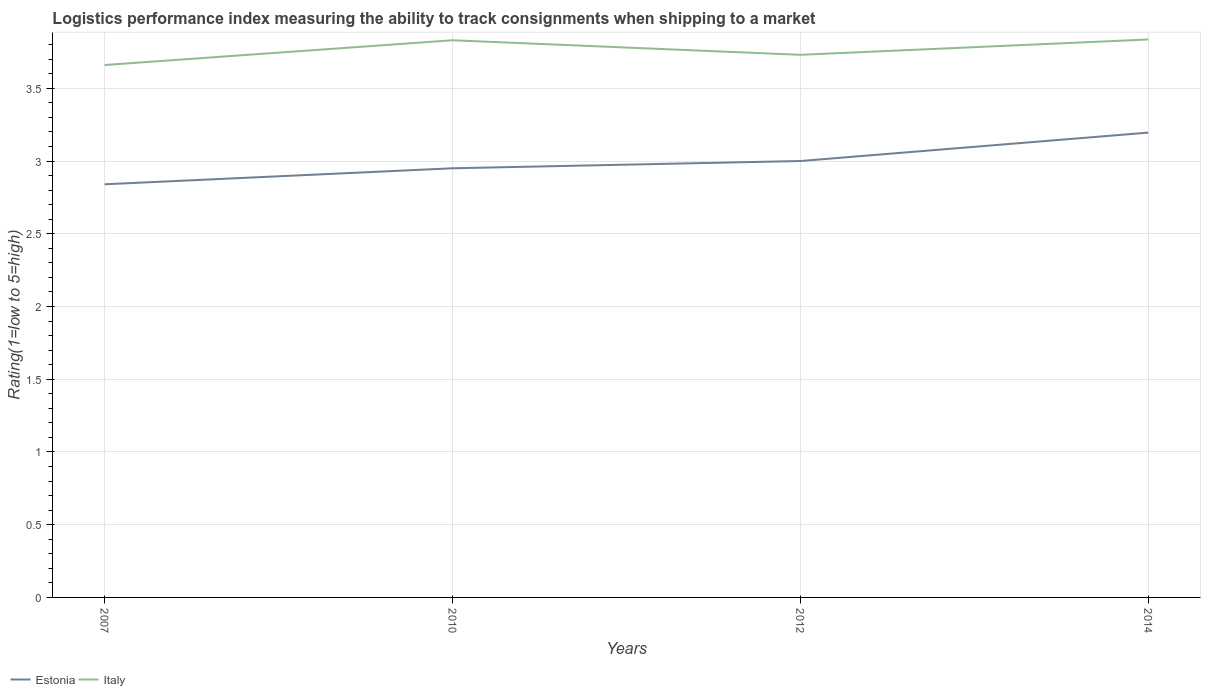How many different coloured lines are there?
Make the answer very short. 2. Is the number of lines equal to the number of legend labels?
Your answer should be compact. Yes. Across all years, what is the maximum Logistic performance index in Estonia?
Provide a succinct answer. 2.84. What is the total Logistic performance index in Estonia in the graph?
Your answer should be very brief. -0.36. What is the difference between the highest and the second highest Logistic performance index in Italy?
Provide a short and direct response. 0.18. What is the difference between the highest and the lowest Logistic performance index in Estonia?
Provide a short and direct response. 2. What is the difference between two consecutive major ticks on the Y-axis?
Your answer should be compact. 0.5. Does the graph contain any zero values?
Make the answer very short. No. Where does the legend appear in the graph?
Provide a succinct answer. Bottom left. What is the title of the graph?
Make the answer very short. Logistics performance index measuring the ability to track consignments when shipping to a market. What is the label or title of the X-axis?
Your answer should be very brief. Years. What is the label or title of the Y-axis?
Keep it short and to the point. Rating(1=low to 5=high). What is the Rating(1=low to 5=high) of Estonia in 2007?
Offer a terse response. 2.84. What is the Rating(1=low to 5=high) of Italy in 2007?
Provide a short and direct response. 3.66. What is the Rating(1=low to 5=high) in Estonia in 2010?
Make the answer very short. 2.95. What is the Rating(1=low to 5=high) of Italy in 2010?
Give a very brief answer. 3.83. What is the Rating(1=low to 5=high) of Italy in 2012?
Provide a short and direct response. 3.73. What is the Rating(1=low to 5=high) in Estonia in 2014?
Offer a terse response. 3.2. What is the Rating(1=low to 5=high) in Italy in 2014?
Ensure brevity in your answer.  3.84. Across all years, what is the maximum Rating(1=low to 5=high) of Estonia?
Provide a short and direct response. 3.2. Across all years, what is the maximum Rating(1=low to 5=high) in Italy?
Give a very brief answer. 3.84. Across all years, what is the minimum Rating(1=low to 5=high) of Estonia?
Provide a succinct answer. 2.84. Across all years, what is the minimum Rating(1=low to 5=high) of Italy?
Your answer should be very brief. 3.66. What is the total Rating(1=low to 5=high) of Estonia in the graph?
Your answer should be compact. 11.99. What is the total Rating(1=low to 5=high) in Italy in the graph?
Ensure brevity in your answer.  15.06. What is the difference between the Rating(1=low to 5=high) of Estonia in 2007 and that in 2010?
Provide a short and direct response. -0.11. What is the difference between the Rating(1=low to 5=high) in Italy in 2007 and that in 2010?
Your response must be concise. -0.17. What is the difference between the Rating(1=low to 5=high) of Estonia in 2007 and that in 2012?
Your response must be concise. -0.16. What is the difference between the Rating(1=low to 5=high) in Italy in 2007 and that in 2012?
Provide a short and direct response. -0.07. What is the difference between the Rating(1=low to 5=high) of Estonia in 2007 and that in 2014?
Give a very brief answer. -0.36. What is the difference between the Rating(1=low to 5=high) in Italy in 2007 and that in 2014?
Give a very brief answer. -0.18. What is the difference between the Rating(1=low to 5=high) of Estonia in 2010 and that in 2012?
Ensure brevity in your answer.  -0.05. What is the difference between the Rating(1=low to 5=high) of Italy in 2010 and that in 2012?
Ensure brevity in your answer.  0.1. What is the difference between the Rating(1=low to 5=high) in Estonia in 2010 and that in 2014?
Offer a terse response. -0.25. What is the difference between the Rating(1=low to 5=high) in Italy in 2010 and that in 2014?
Offer a very short reply. -0.01. What is the difference between the Rating(1=low to 5=high) in Estonia in 2012 and that in 2014?
Provide a succinct answer. -0.2. What is the difference between the Rating(1=low to 5=high) of Italy in 2012 and that in 2014?
Your response must be concise. -0.11. What is the difference between the Rating(1=low to 5=high) in Estonia in 2007 and the Rating(1=low to 5=high) in Italy in 2010?
Ensure brevity in your answer.  -0.99. What is the difference between the Rating(1=low to 5=high) in Estonia in 2007 and the Rating(1=low to 5=high) in Italy in 2012?
Ensure brevity in your answer.  -0.89. What is the difference between the Rating(1=low to 5=high) of Estonia in 2007 and the Rating(1=low to 5=high) of Italy in 2014?
Your response must be concise. -1. What is the difference between the Rating(1=low to 5=high) in Estonia in 2010 and the Rating(1=low to 5=high) in Italy in 2012?
Give a very brief answer. -0.78. What is the difference between the Rating(1=low to 5=high) of Estonia in 2010 and the Rating(1=low to 5=high) of Italy in 2014?
Keep it short and to the point. -0.89. What is the difference between the Rating(1=low to 5=high) of Estonia in 2012 and the Rating(1=low to 5=high) of Italy in 2014?
Provide a short and direct response. -0.84. What is the average Rating(1=low to 5=high) of Estonia per year?
Offer a terse response. 3. What is the average Rating(1=low to 5=high) in Italy per year?
Your answer should be very brief. 3.76. In the year 2007, what is the difference between the Rating(1=low to 5=high) in Estonia and Rating(1=low to 5=high) in Italy?
Make the answer very short. -0.82. In the year 2010, what is the difference between the Rating(1=low to 5=high) in Estonia and Rating(1=low to 5=high) in Italy?
Provide a short and direct response. -0.88. In the year 2012, what is the difference between the Rating(1=low to 5=high) in Estonia and Rating(1=low to 5=high) in Italy?
Provide a succinct answer. -0.73. In the year 2014, what is the difference between the Rating(1=low to 5=high) of Estonia and Rating(1=low to 5=high) of Italy?
Keep it short and to the point. -0.64. What is the ratio of the Rating(1=low to 5=high) in Estonia in 2007 to that in 2010?
Ensure brevity in your answer.  0.96. What is the ratio of the Rating(1=low to 5=high) of Italy in 2007 to that in 2010?
Your answer should be very brief. 0.96. What is the ratio of the Rating(1=low to 5=high) in Estonia in 2007 to that in 2012?
Make the answer very short. 0.95. What is the ratio of the Rating(1=low to 5=high) of Italy in 2007 to that in 2012?
Offer a very short reply. 0.98. What is the ratio of the Rating(1=low to 5=high) in Estonia in 2007 to that in 2014?
Offer a very short reply. 0.89. What is the ratio of the Rating(1=low to 5=high) of Italy in 2007 to that in 2014?
Offer a terse response. 0.95. What is the ratio of the Rating(1=low to 5=high) in Estonia in 2010 to that in 2012?
Provide a succinct answer. 0.98. What is the ratio of the Rating(1=low to 5=high) in Italy in 2010 to that in 2012?
Provide a short and direct response. 1.03. What is the ratio of the Rating(1=low to 5=high) of Estonia in 2010 to that in 2014?
Keep it short and to the point. 0.92. What is the ratio of the Rating(1=low to 5=high) in Italy in 2010 to that in 2014?
Keep it short and to the point. 1. What is the ratio of the Rating(1=low to 5=high) in Estonia in 2012 to that in 2014?
Give a very brief answer. 0.94. What is the ratio of the Rating(1=low to 5=high) of Italy in 2012 to that in 2014?
Offer a terse response. 0.97. What is the difference between the highest and the second highest Rating(1=low to 5=high) of Estonia?
Offer a terse response. 0.2. What is the difference between the highest and the second highest Rating(1=low to 5=high) in Italy?
Provide a short and direct response. 0.01. What is the difference between the highest and the lowest Rating(1=low to 5=high) of Estonia?
Offer a very short reply. 0.36. What is the difference between the highest and the lowest Rating(1=low to 5=high) in Italy?
Offer a terse response. 0.18. 